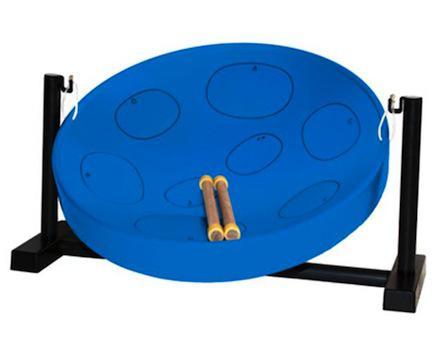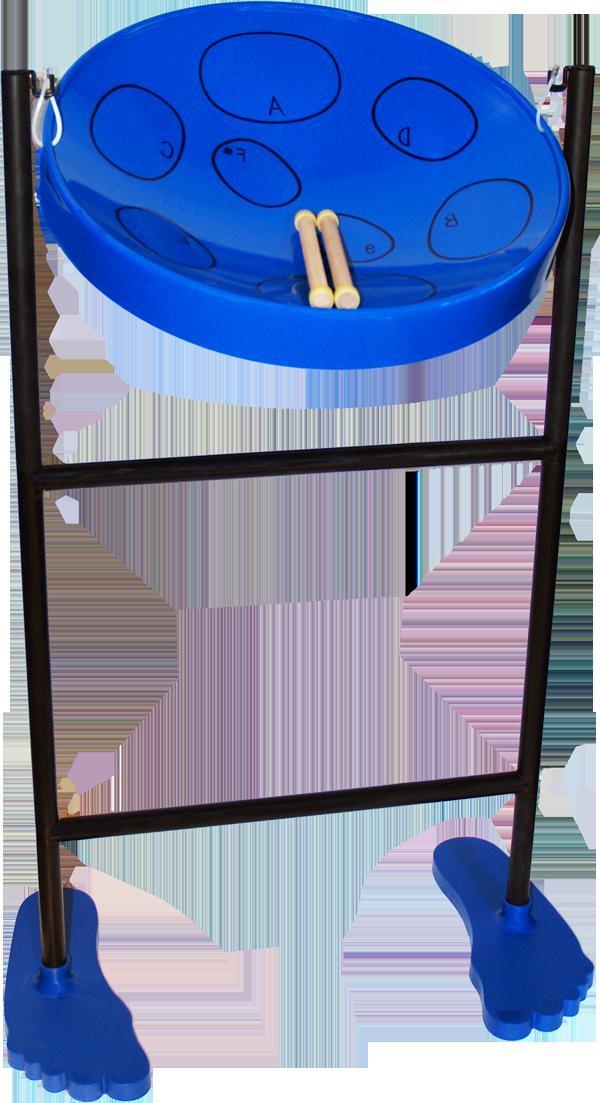The first image is the image on the left, the second image is the image on the right. For the images displayed, is the sentence "All the drums are blue." factually correct? Answer yes or no. Yes. 